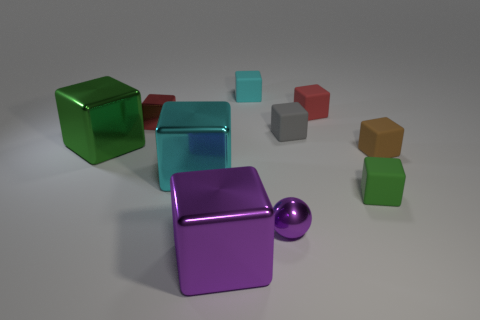What material is the cube that is both right of the small red metal cube and on the left side of the large purple thing? metal 